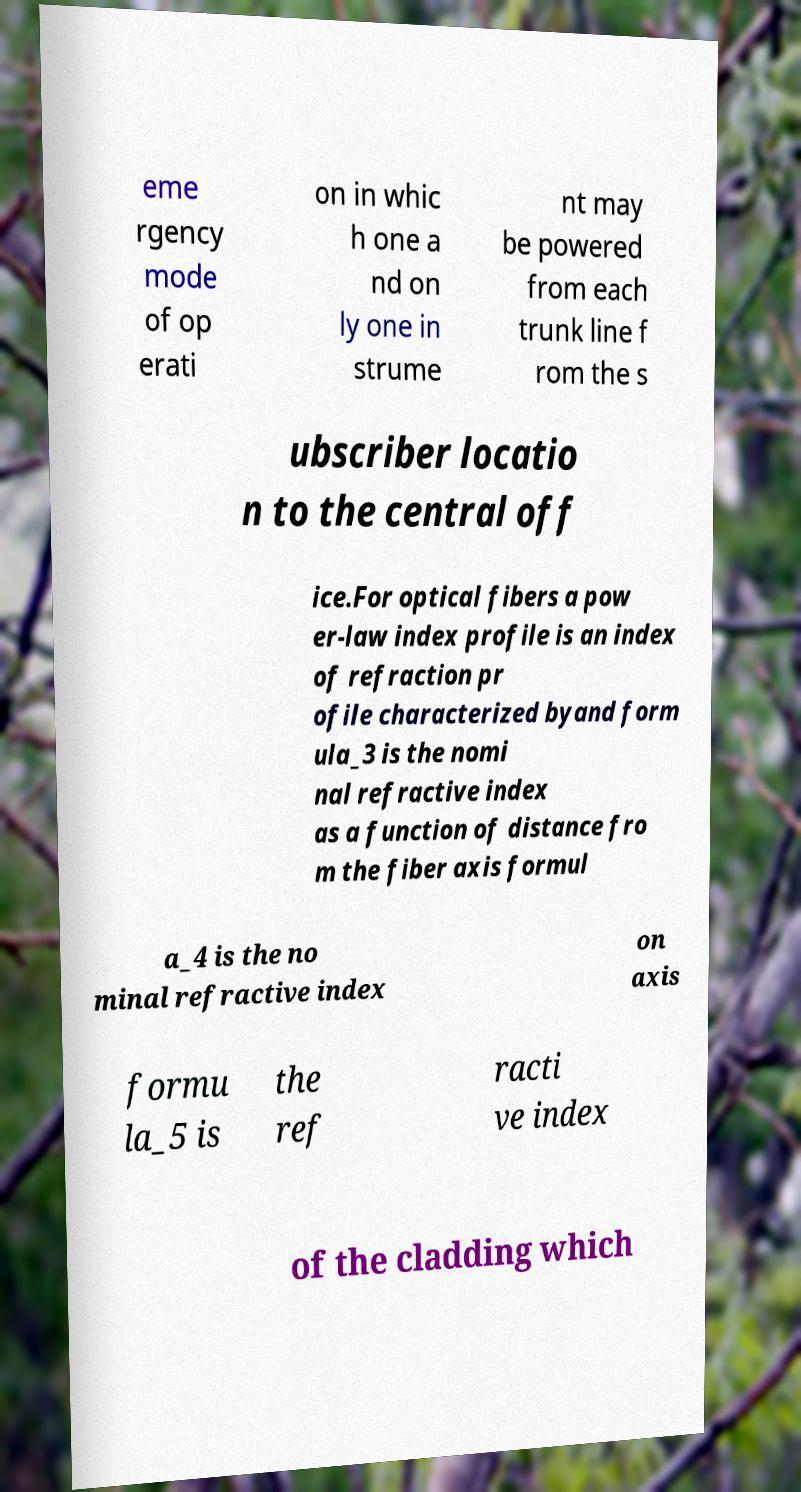Can you accurately transcribe the text from the provided image for me? eme rgency mode of op erati on in whic h one a nd on ly one in strume nt may be powered from each trunk line f rom the s ubscriber locatio n to the central off ice.For optical fibers a pow er-law index profile is an index of refraction pr ofile characterized byand form ula_3 is the nomi nal refractive index as a function of distance fro m the fiber axis formul a_4 is the no minal refractive index on axis formu la_5 is the ref racti ve index of the cladding which 